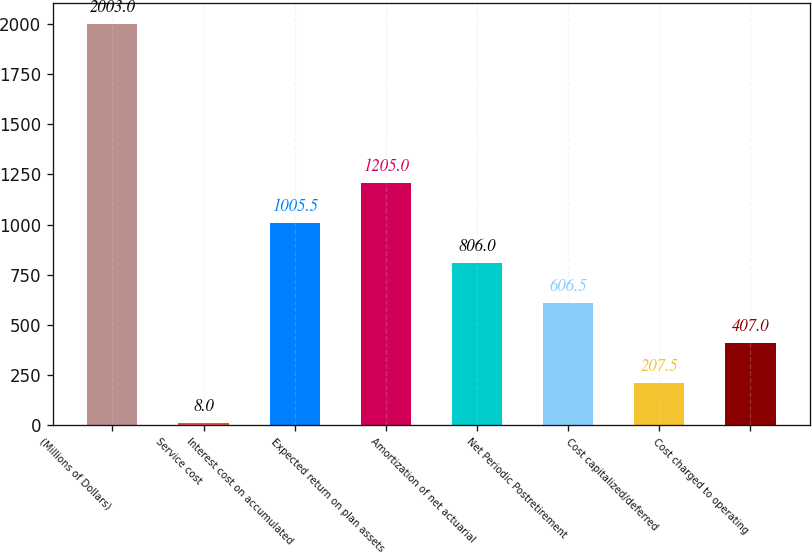<chart> <loc_0><loc_0><loc_500><loc_500><bar_chart><fcel>(Millions of Dollars)<fcel>Service cost<fcel>Interest cost on accumulated<fcel>Expected return on plan assets<fcel>Amortization of net actuarial<fcel>Net Periodic Postretirement<fcel>Cost capitalized/deferred<fcel>Cost charged to operating<nl><fcel>2003<fcel>8<fcel>1005.5<fcel>1205<fcel>806<fcel>606.5<fcel>207.5<fcel>407<nl></chart> 